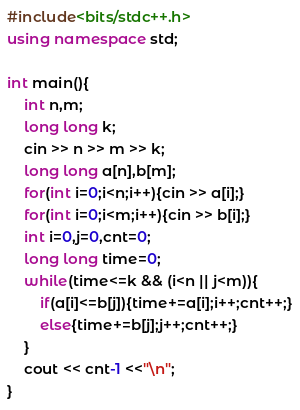Convert code to text. <code><loc_0><loc_0><loc_500><loc_500><_C++_>#include<bits/stdc++.h>
using namespace std;

int main(){
    int n,m;
    long long k;
    cin >> n >> m >> k;
    long long a[n],b[m];
    for(int i=0;i<n;i++){cin >> a[i];}
    for(int i=0;i<m;i++){cin >> b[i];}
    int i=0,j=0,cnt=0;
    long long time=0;
    while(time<=k && (i<n || j<m)){
        if(a[i]<=b[j]){time+=a[i];i++;cnt++;}
        else{time+=b[j];j++;cnt++;}
    }
    cout << cnt-1 <<"\n";
}
</code> 